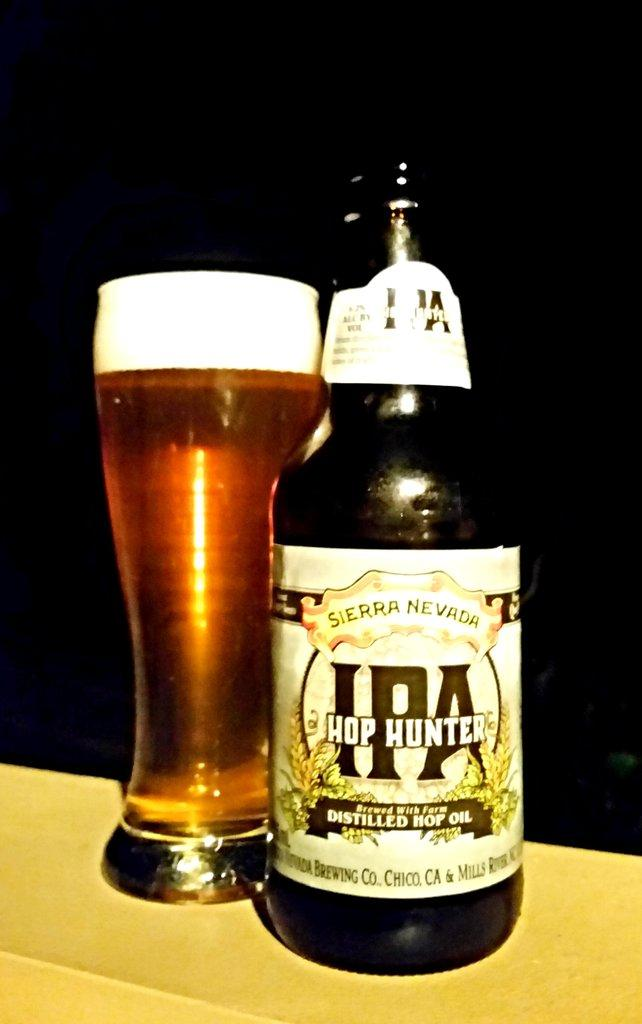<image>
Give a short and clear explanation of the subsequent image. Hop Hunter is brewed with distilled hop oil according to the bottle of it on the table. 